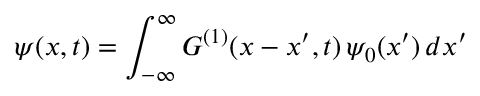Convert formula to latex. <formula><loc_0><loc_0><loc_500><loc_500>\psi ( x , t ) = \int _ { - \infty } ^ { \infty } G ^ { ( 1 ) } ( x - x ^ { \prime } , t ) \, \psi _ { 0 } ( x ^ { \prime } ) \, d x ^ { \prime }</formula> 